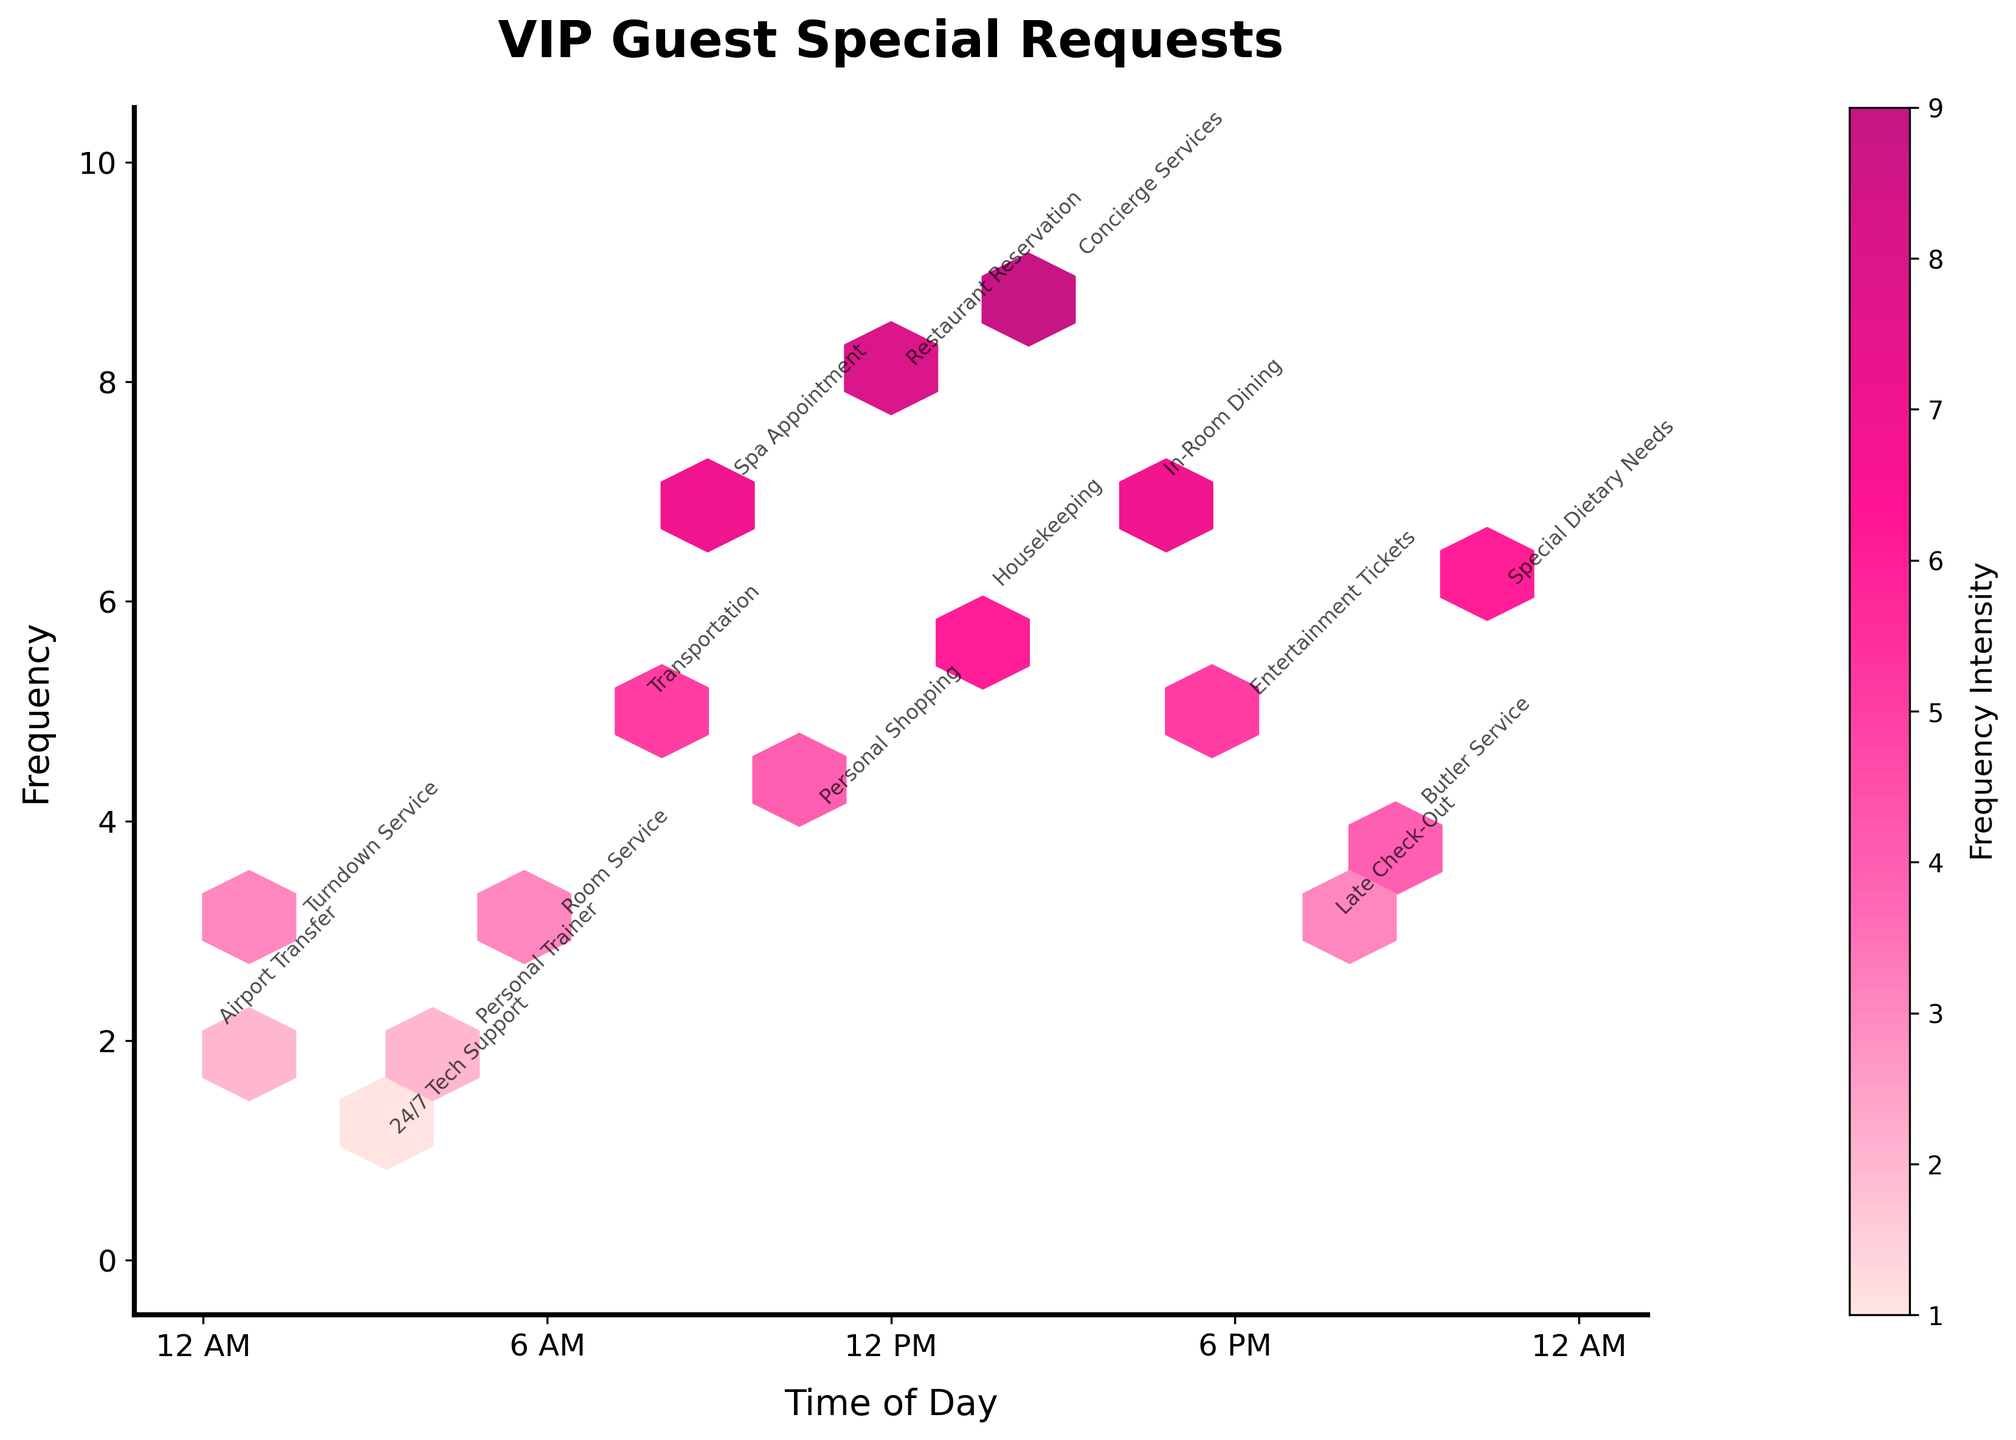What is the title of the figure? The title is usually located at the top of the figure. In this case, it is clearly labeled in bold text.
Answer: VIP Guest Special Requests How many grids are used in the hexbin plot? The grid size can be inferred indirectly from the parameter in the description "gridsize=15," which means there are 15 grids along both the x and y axes.
Answer: 15 What time of day has the highest frequency of special requests? Observing the plot, the highest frequency on the y-axis corresponds to around 3 PM on the x-axis.
Answer: 3 PM Which special request type has the least frequency and at what time? The hexbin plot shows the lowest frequency at 3 AM, which is annotated with "24/7 Tech Support."
Answer: 3 AM, 24/7 Tech Support Compare the frequency intensity of Housekeeping and Concierge Services. Which one is higher and by how much? Taking a look at the color intensity and the numerical values, Housekeeping has a frequency of 6, whereas Concierge Services has a frequency of 9. The difference is 9 - 6 = 3.
Answer: Concierge Services by 3 What is the average frequency of requests made before noon? Adding the frequencies for requests before noon (3 + 5 + 7 + 4 + 8) and dividing by the number of requests (which is 5), we get (3 + 5 + 7 + 4 + 8) / 5 = 5.4.
Answer: 5.4 At what time are the special dietary needs typically requested, and how frequent are they? The annotation for "Special Dietary Needs" shows that these requests are made at 10:30 PM with a frequency of 6.
Answer: 10:30 PM, 6 Which request type appears closest to midnight and what is its frequency? The requests made around 12 AM (both at the start and end of the 24-hour period) are "Airport Transfer" with a frequency of 2.
Answer: Airport Transfer, 2 Is there any request type that occurs both before and after noon? If so, which one(s) and how frequent are they? Based on the plot's annotations, no request type appears multiple times at different times of the day; each request type is shown only at one specific time.
Answer: None How does the frequency of late check-out requests compare to personal shopping requests, and what times do they occur? The plot shows "Late Check-Out" requests at 7:30 PM with a frequency of 3, and "Personal Shopping" requests at 10:30 AM with a frequency of 4. The difference in frequencies is 4 - 3 = 1 in favor of Personal Shopping.
Answer: Personal Shopping by 1 